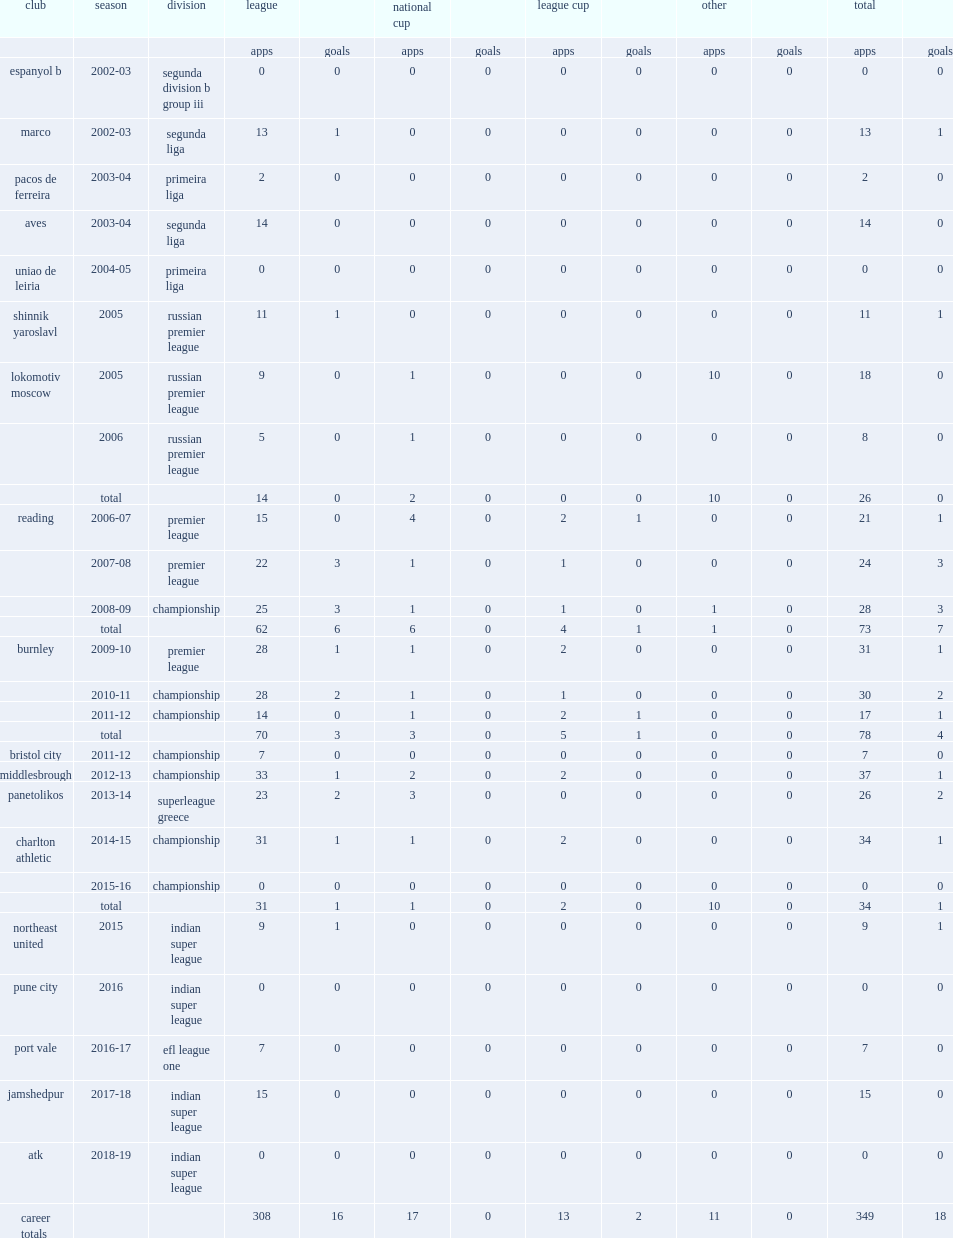In 2015, which league was bikey in the northeast united? Indian super league. Could you help me parse every detail presented in this table? {'header': ['club', 'season', 'division', 'league', '', 'national cup', '', 'league cup', '', 'other', '', 'total', ''], 'rows': [['', '', '', 'apps', 'goals', 'apps', 'goals', 'apps', 'goals', 'apps', 'goals', 'apps', 'goals'], ['espanyol b', '2002-03', 'segunda division b group iii', '0', '0', '0', '0', '0', '0', '0', '0', '0', '0'], ['marco', '2002-03', 'segunda liga', '13', '1', '0', '0', '0', '0', '0', '0', '13', '1'], ['pacos de ferreira', '2003-04', 'primeira liga', '2', '0', '0', '0', '0', '0', '0', '0', '2', '0'], ['aves', '2003-04', 'segunda liga', '14', '0', '0', '0', '0', '0', '0', '0', '14', '0'], ['uniao de leiria', '2004-05', 'primeira liga', '0', '0', '0', '0', '0', '0', '0', '0', '0', '0'], ['shinnik yaroslavl', '2005', 'russian premier league', '11', '1', '0', '0', '0', '0', '0', '0', '11', '1'], ['lokomotiv moscow', '2005', 'russian premier league', '9', '0', '1', '0', '0', '0', '10', '0', '18', '0'], ['', '2006', 'russian premier league', '5', '0', '1', '0', '0', '0', '0', '0', '8', '0'], ['', 'total', '', '14', '0', '2', '0', '0', '0', '10', '0', '26', '0'], ['reading', '2006-07', 'premier league', '15', '0', '4', '0', '2', '1', '0', '0', '21', '1'], ['', '2007-08', 'premier league', '22', '3', '1', '0', '1', '0', '0', '0', '24', '3'], ['', '2008-09', 'championship', '25', '3', '1', '0', '1', '0', '1', '0', '28', '3'], ['', 'total', '', '62', '6', '6', '0', '4', '1', '1', '0', '73', '7'], ['burnley', '2009-10', 'premier league', '28', '1', '1', '0', '2', '0', '0', '0', '31', '1'], ['', '2010-11', 'championship', '28', '2', '1', '0', '1', '0', '0', '0', '30', '2'], ['', '2011-12', 'championship', '14', '0', '1', '0', '2', '1', '0', '0', '17', '1'], ['', 'total', '', '70', '3', '3', '0', '5', '1', '0', '0', '78', '4'], ['bristol city', '2011-12', 'championship', '7', '0', '0', '0', '0', '0', '0', '0', '7', '0'], ['middlesbrough', '2012-13', 'championship', '33', '1', '2', '0', '2', '0', '0', '0', '37', '1'], ['panetolikos', '2013-14', 'superleague greece', '23', '2', '3', '0', '0', '0', '0', '0', '26', '2'], ['charlton athletic', '2014-15', 'championship', '31', '1', '1', '0', '2', '0', '0', '0', '34', '1'], ['', '2015-16', 'championship', '0', '0', '0', '0', '0', '0', '0', '0', '0', '0'], ['', 'total', '', '31', '1', '1', '0', '2', '0', '10', '0', '34', '1'], ['northeast united', '2015', 'indian super league', '9', '1', '0', '0', '0', '0', '0', '0', '9', '1'], ['pune city', '2016', 'indian super league', '0', '0', '0', '0', '0', '0', '0', '0', '0', '0'], ['port vale', '2016-17', 'efl league one', '7', '0', '0', '0', '0', '0', '0', '0', '7', '0'], ['jamshedpur', '2017-18', 'indian super league', '15', '0', '0', '0', '0', '0', '0', '0', '15', '0'], ['atk', '2018-19', 'indian super league', '0', '0', '0', '0', '0', '0', '0', '0', '0', '0'], ['career totals', '', '', '308', '16', '17', '0', '13', '2', '11', '0', '349', '18']]} 